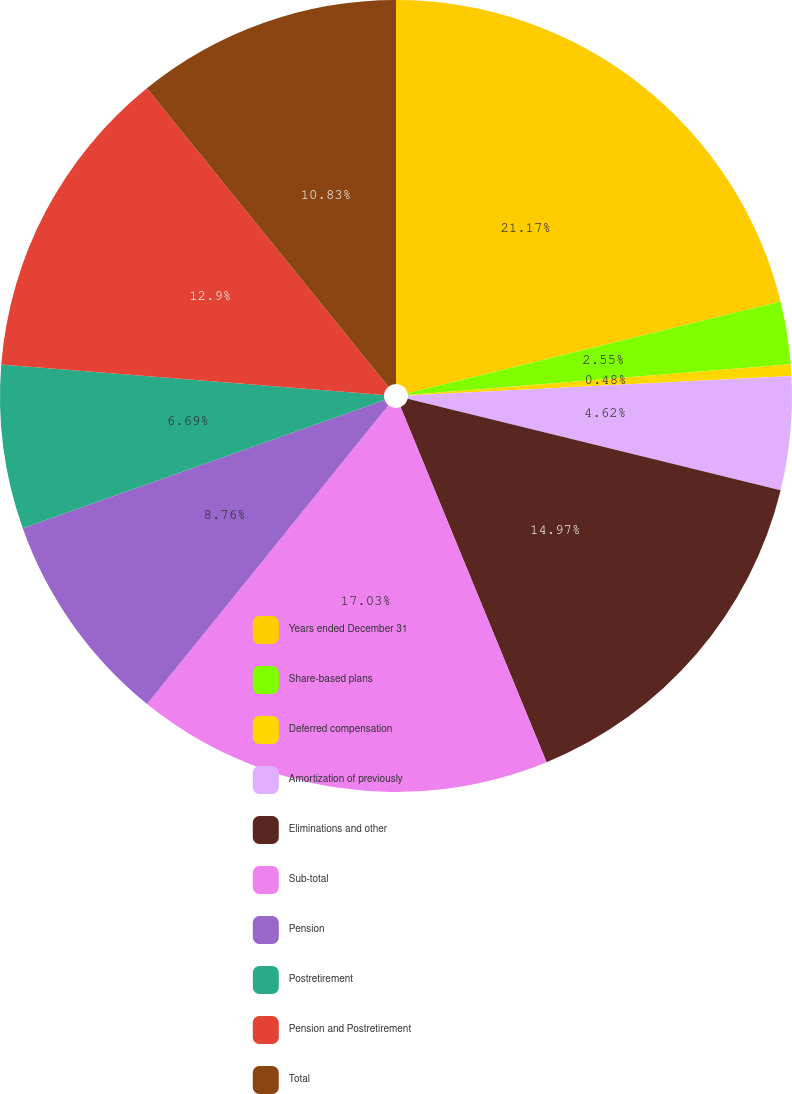Convert chart. <chart><loc_0><loc_0><loc_500><loc_500><pie_chart><fcel>Years ended December 31<fcel>Share-based plans<fcel>Deferred compensation<fcel>Amortization of previously<fcel>Eliminations and other<fcel>Sub-total<fcel>Pension<fcel>Postretirement<fcel>Pension and Postretirement<fcel>Total<nl><fcel>21.17%<fcel>2.55%<fcel>0.48%<fcel>4.62%<fcel>14.97%<fcel>17.03%<fcel>8.76%<fcel>6.69%<fcel>12.9%<fcel>10.83%<nl></chart> 